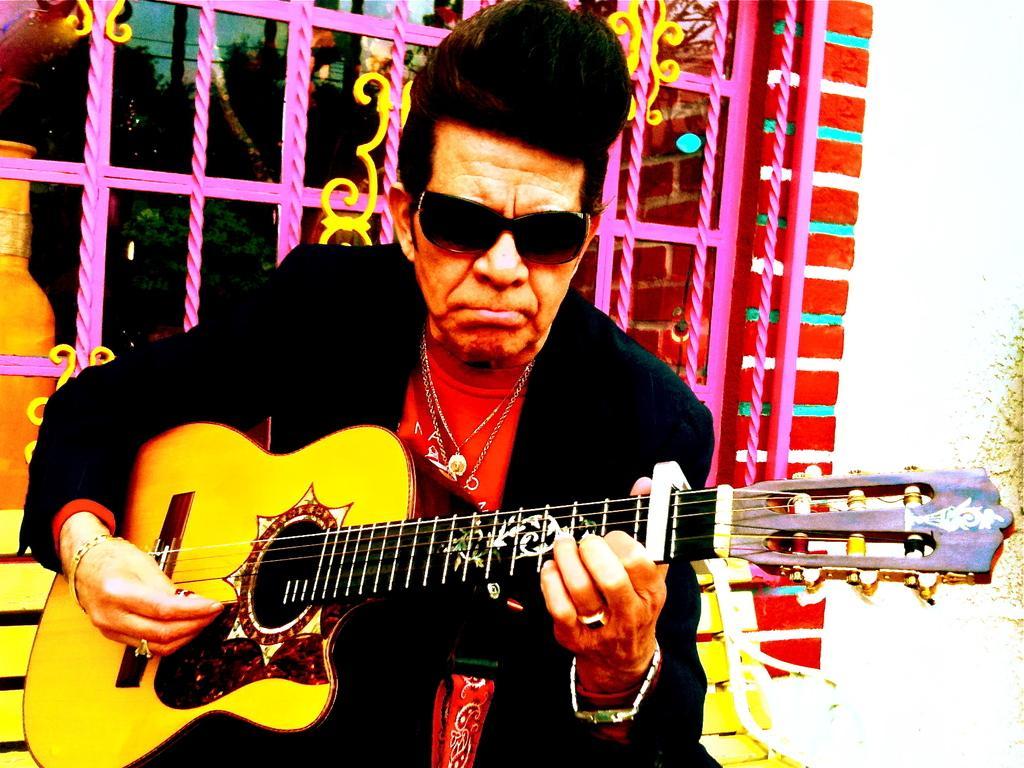Could you give a brief overview of what you see in this image? In this image i can see a person holding a guitar. In the background i can see a window and trees. 